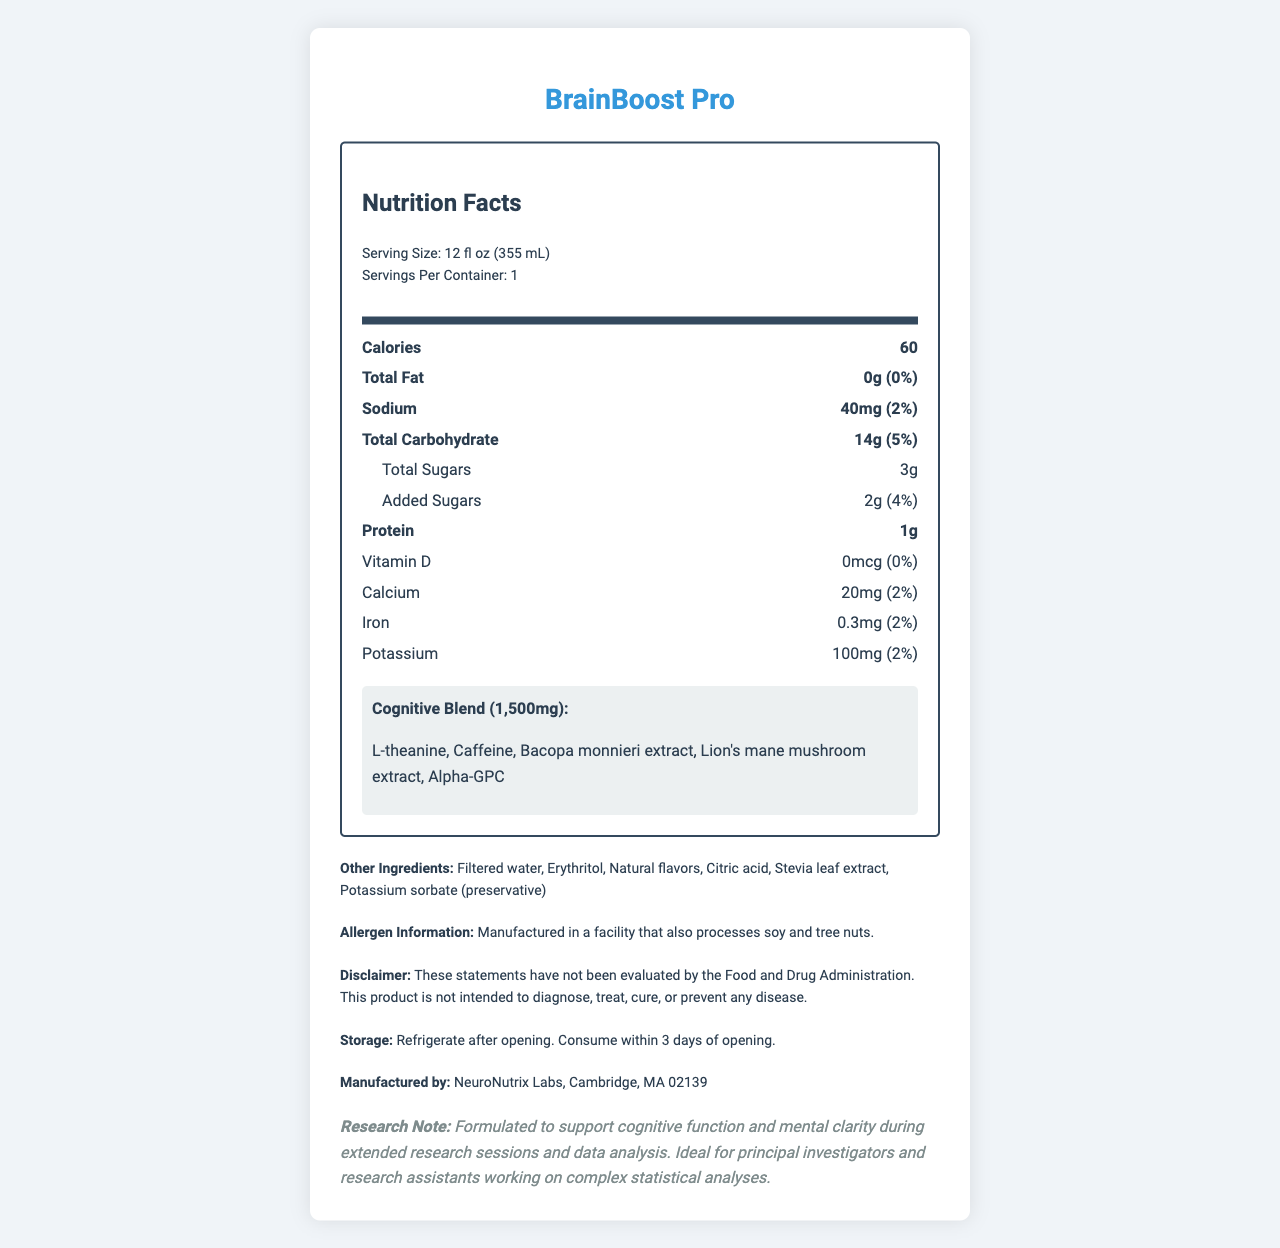what is the serving size of BrainBoost Pro? The serving size is listed under the serving information at the top of the nutrition label.
Answer: 12 fl oz (355 mL) how many calories are in a serving of BrainBoost Pro? The calorie content per serving is stated clearly in the bold section under the Nutrition Facts header.
Answer: 60 how much protein does BrainBoost Pro contain? The amount of protein is listed in the bold section of the nutrition label.
Answer: 1g what is the range of daily value percentages for sodium and potassium? Both sodium and potassium have a daily value percentage of 2%, as displayed next to their amounts in the nutrition label.
Answer: 2% what is the amount of the Cognitive Blend in BrainBoost Pro? The Cognitive Blend amount is specified near the bottom of the nutrition label under the Cognitive Blend section.
Answer: 1,500mg what are the main ingredients in BrainBoost Pro's Cognitive Blend? A. Bacopa monnieri extract, Stevia leaf extract, Citric acid B. L-theanine, Caffeine, Bacopa monnieri extract, Alpha-GPC C. Filtered water, Erythritol, Potassium sorbate D. L-theanine, Caffeine, Lion's mane mushroom extract, Alpha-GPC, Bacopa monnieri extract The Cognitive Blend ingredients are L-theanine, Caffeine, Bacopa monnieri extract, Lion's mane mushroom extract, and Alpha-GPC, as listed in the specific Cognitive Blend section.
Answer: D which ingredient is listed first in the Other Ingredients section? 1. Erythritol 2. Filtered water 3. Natural flavors 4. Stevia leaf extract Filtered water is the first ingredient listed under the Other Ingredients section, as shown in the label.
Answer: 2 is the product BrainBoost Pro suitable for people with soy allergies? The allergen information indicates that it is manufactured in a facility that processes soy, which may not be suitable for people with soy allergies.
Answer: No what should you do after opening BrainBoost Pro? The storage instructions specify that the product should be refrigerated and consumed within 3 days after opening.
Answer: Refrigerate after opening. Consume within 3 days of opening. who manufactures BrainBoost Pro? The manufacturer's details are provided at the bottom of the document.
Answer: NeuroNutrix Labs, Cambridge, MA 02139 does BrainBoost Pro provide any vitamin D? A. Yes, 0mcg B. Yes, 20mg C. No, 0mcg D. No, 40mg The nutrition facts indicate 0mcg of Vitamin D, thus it provides none.
Answer: C what is the main purpose of the research note provided in the document? The research note specifically states that the product is created to support cognitive function and mental clarity.
Answer: Formulated to support cognitive function and mental clarity during extended research sessions and data analysis. is the total carbohydrate content higher than the total sugar content in BrainBoost Pro? The carbohydrate content is 14g while the total sugar content is only 3g.
Answer: Yes describe the major nutritional aspects and special features of BrainBoost Pro The document highlights the beverage's nutritional benefits, its targeted cognitive support formula, low caloric content, and specific storage and allergen details.
Answer: BrainBoost Pro offers a cognitive-enhancing formula with only 60 calories per serving. It contains minimal fat, moderate carbohydrates, a blend of cognitive-enhancing ingredients, and low sugars. Special features include a proprietary Cognitive Blend and detailed allergen information. what are the specific benefits of consuming L-theanine and Bacopa monnieri extract found in BrainBoost Pro? The document states the ingredients but does not provide specific benefits of L-theanine or Bacopa monnieri extract.
Answer: Not enough information 